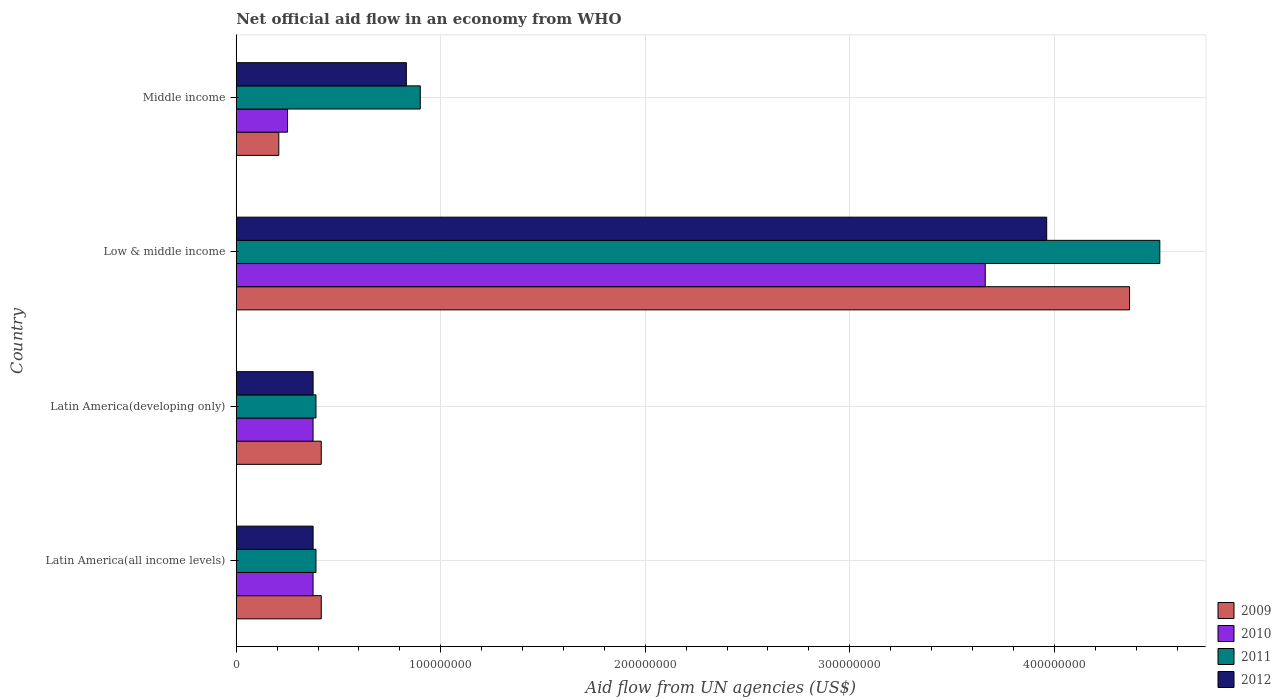How many groups of bars are there?
Give a very brief answer. 4. Are the number of bars per tick equal to the number of legend labels?
Keep it short and to the point. Yes. How many bars are there on the 3rd tick from the top?
Your answer should be very brief. 4. What is the label of the 3rd group of bars from the top?
Keep it short and to the point. Latin America(developing only). What is the net official aid flow in 2010 in Low & middle income?
Ensure brevity in your answer.  3.66e+08. Across all countries, what is the maximum net official aid flow in 2009?
Keep it short and to the point. 4.37e+08. Across all countries, what is the minimum net official aid flow in 2012?
Keep it short and to the point. 3.76e+07. In which country was the net official aid flow in 2011 minimum?
Offer a very short reply. Latin America(all income levels). What is the total net official aid flow in 2009 in the graph?
Your response must be concise. 5.41e+08. What is the difference between the net official aid flow in 2010 in Low & middle income and that in Middle income?
Your answer should be compact. 3.41e+08. What is the difference between the net official aid flow in 2012 in Middle income and the net official aid flow in 2009 in Low & middle income?
Your answer should be compact. -3.54e+08. What is the average net official aid flow in 2011 per country?
Offer a very short reply. 1.55e+08. What is the ratio of the net official aid flow in 2011 in Latin America(all income levels) to that in Low & middle income?
Provide a succinct answer. 0.09. What is the difference between the highest and the second highest net official aid flow in 2012?
Give a very brief answer. 3.13e+08. What is the difference between the highest and the lowest net official aid flow in 2012?
Offer a terse response. 3.59e+08. Is it the case that in every country, the sum of the net official aid flow in 2010 and net official aid flow in 2009 is greater than the sum of net official aid flow in 2011 and net official aid flow in 2012?
Offer a terse response. No. What does the 3rd bar from the top in Middle income represents?
Make the answer very short. 2010. What does the 4th bar from the bottom in Latin America(developing only) represents?
Provide a short and direct response. 2012. Does the graph contain any zero values?
Make the answer very short. No. Does the graph contain grids?
Give a very brief answer. Yes. Where does the legend appear in the graph?
Keep it short and to the point. Bottom right. How are the legend labels stacked?
Your answer should be compact. Vertical. What is the title of the graph?
Give a very brief answer. Net official aid flow in an economy from WHO. Does "2010" appear as one of the legend labels in the graph?
Provide a succinct answer. Yes. What is the label or title of the X-axis?
Give a very brief answer. Aid flow from UN agencies (US$). What is the Aid flow from UN agencies (US$) in 2009 in Latin America(all income levels)?
Provide a succinct answer. 4.16e+07. What is the Aid flow from UN agencies (US$) in 2010 in Latin America(all income levels)?
Your answer should be very brief. 3.76e+07. What is the Aid flow from UN agencies (US$) of 2011 in Latin America(all income levels)?
Your answer should be very brief. 3.90e+07. What is the Aid flow from UN agencies (US$) of 2012 in Latin America(all income levels)?
Provide a short and direct response. 3.76e+07. What is the Aid flow from UN agencies (US$) of 2009 in Latin America(developing only)?
Your answer should be compact. 4.16e+07. What is the Aid flow from UN agencies (US$) in 2010 in Latin America(developing only)?
Provide a succinct answer. 3.76e+07. What is the Aid flow from UN agencies (US$) of 2011 in Latin America(developing only)?
Keep it short and to the point. 3.90e+07. What is the Aid flow from UN agencies (US$) of 2012 in Latin America(developing only)?
Provide a succinct answer. 3.76e+07. What is the Aid flow from UN agencies (US$) of 2009 in Low & middle income?
Give a very brief answer. 4.37e+08. What is the Aid flow from UN agencies (US$) in 2010 in Low & middle income?
Provide a succinct answer. 3.66e+08. What is the Aid flow from UN agencies (US$) of 2011 in Low & middle income?
Your response must be concise. 4.52e+08. What is the Aid flow from UN agencies (US$) in 2012 in Low & middle income?
Give a very brief answer. 3.96e+08. What is the Aid flow from UN agencies (US$) in 2009 in Middle income?
Provide a short and direct response. 2.08e+07. What is the Aid flow from UN agencies (US$) in 2010 in Middle income?
Ensure brevity in your answer.  2.51e+07. What is the Aid flow from UN agencies (US$) in 2011 in Middle income?
Your response must be concise. 9.00e+07. What is the Aid flow from UN agencies (US$) in 2012 in Middle income?
Make the answer very short. 8.32e+07. Across all countries, what is the maximum Aid flow from UN agencies (US$) of 2009?
Your response must be concise. 4.37e+08. Across all countries, what is the maximum Aid flow from UN agencies (US$) of 2010?
Keep it short and to the point. 3.66e+08. Across all countries, what is the maximum Aid flow from UN agencies (US$) of 2011?
Offer a very short reply. 4.52e+08. Across all countries, what is the maximum Aid flow from UN agencies (US$) of 2012?
Ensure brevity in your answer.  3.96e+08. Across all countries, what is the minimum Aid flow from UN agencies (US$) in 2009?
Your response must be concise. 2.08e+07. Across all countries, what is the minimum Aid flow from UN agencies (US$) in 2010?
Offer a terse response. 2.51e+07. Across all countries, what is the minimum Aid flow from UN agencies (US$) in 2011?
Give a very brief answer. 3.90e+07. Across all countries, what is the minimum Aid flow from UN agencies (US$) of 2012?
Offer a very short reply. 3.76e+07. What is the total Aid flow from UN agencies (US$) in 2009 in the graph?
Offer a very short reply. 5.41e+08. What is the total Aid flow from UN agencies (US$) in 2010 in the graph?
Make the answer very short. 4.66e+08. What is the total Aid flow from UN agencies (US$) of 2011 in the graph?
Keep it short and to the point. 6.20e+08. What is the total Aid flow from UN agencies (US$) in 2012 in the graph?
Offer a terse response. 5.55e+08. What is the difference between the Aid flow from UN agencies (US$) in 2009 in Latin America(all income levels) and that in Latin America(developing only)?
Your response must be concise. 0. What is the difference between the Aid flow from UN agencies (US$) in 2009 in Latin America(all income levels) and that in Low & middle income?
Give a very brief answer. -3.95e+08. What is the difference between the Aid flow from UN agencies (US$) in 2010 in Latin America(all income levels) and that in Low & middle income?
Your answer should be very brief. -3.29e+08. What is the difference between the Aid flow from UN agencies (US$) in 2011 in Latin America(all income levels) and that in Low & middle income?
Your response must be concise. -4.13e+08. What is the difference between the Aid flow from UN agencies (US$) of 2012 in Latin America(all income levels) and that in Low & middle income?
Keep it short and to the point. -3.59e+08. What is the difference between the Aid flow from UN agencies (US$) in 2009 in Latin America(all income levels) and that in Middle income?
Your response must be concise. 2.08e+07. What is the difference between the Aid flow from UN agencies (US$) of 2010 in Latin America(all income levels) and that in Middle income?
Your answer should be compact. 1.25e+07. What is the difference between the Aid flow from UN agencies (US$) in 2011 in Latin America(all income levels) and that in Middle income?
Provide a succinct answer. -5.10e+07. What is the difference between the Aid flow from UN agencies (US$) in 2012 in Latin America(all income levels) and that in Middle income?
Your answer should be compact. -4.56e+07. What is the difference between the Aid flow from UN agencies (US$) in 2009 in Latin America(developing only) and that in Low & middle income?
Ensure brevity in your answer.  -3.95e+08. What is the difference between the Aid flow from UN agencies (US$) of 2010 in Latin America(developing only) and that in Low & middle income?
Keep it short and to the point. -3.29e+08. What is the difference between the Aid flow from UN agencies (US$) of 2011 in Latin America(developing only) and that in Low & middle income?
Keep it short and to the point. -4.13e+08. What is the difference between the Aid flow from UN agencies (US$) of 2012 in Latin America(developing only) and that in Low & middle income?
Provide a succinct answer. -3.59e+08. What is the difference between the Aid flow from UN agencies (US$) in 2009 in Latin America(developing only) and that in Middle income?
Give a very brief answer. 2.08e+07. What is the difference between the Aid flow from UN agencies (US$) in 2010 in Latin America(developing only) and that in Middle income?
Provide a short and direct response. 1.25e+07. What is the difference between the Aid flow from UN agencies (US$) of 2011 in Latin America(developing only) and that in Middle income?
Keep it short and to the point. -5.10e+07. What is the difference between the Aid flow from UN agencies (US$) in 2012 in Latin America(developing only) and that in Middle income?
Provide a short and direct response. -4.56e+07. What is the difference between the Aid flow from UN agencies (US$) in 2009 in Low & middle income and that in Middle income?
Provide a short and direct response. 4.16e+08. What is the difference between the Aid flow from UN agencies (US$) in 2010 in Low & middle income and that in Middle income?
Offer a terse response. 3.41e+08. What is the difference between the Aid flow from UN agencies (US$) of 2011 in Low & middle income and that in Middle income?
Your answer should be compact. 3.62e+08. What is the difference between the Aid flow from UN agencies (US$) in 2012 in Low & middle income and that in Middle income?
Your answer should be compact. 3.13e+08. What is the difference between the Aid flow from UN agencies (US$) in 2009 in Latin America(all income levels) and the Aid flow from UN agencies (US$) in 2010 in Latin America(developing only)?
Provide a short and direct response. 4.01e+06. What is the difference between the Aid flow from UN agencies (US$) in 2009 in Latin America(all income levels) and the Aid flow from UN agencies (US$) in 2011 in Latin America(developing only)?
Offer a terse response. 2.59e+06. What is the difference between the Aid flow from UN agencies (US$) in 2009 in Latin America(all income levels) and the Aid flow from UN agencies (US$) in 2012 in Latin America(developing only)?
Your response must be concise. 3.99e+06. What is the difference between the Aid flow from UN agencies (US$) in 2010 in Latin America(all income levels) and the Aid flow from UN agencies (US$) in 2011 in Latin America(developing only)?
Ensure brevity in your answer.  -1.42e+06. What is the difference between the Aid flow from UN agencies (US$) in 2011 in Latin America(all income levels) and the Aid flow from UN agencies (US$) in 2012 in Latin America(developing only)?
Ensure brevity in your answer.  1.40e+06. What is the difference between the Aid flow from UN agencies (US$) of 2009 in Latin America(all income levels) and the Aid flow from UN agencies (US$) of 2010 in Low & middle income?
Your response must be concise. -3.25e+08. What is the difference between the Aid flow from UN agencies (US$) of 2009 in Latin America(all income levels) and the Aid flow from UN agencies (US$) of 2011 in Low & middle income?
Your answer should be very brief. -4.10e+08. What is the difference between the Aid flow from UN agencies (US$) of 2009 in Latin America(all income levels) and the Aid flow from UN agencies (US$) of 2012 in Low & middle income?
Give a very brief answer. -3.55e+08. What is the difference between the Aid flow from UN agencies (US$) in 2010 in Latin America(all income levels) and the Aid flow from UN agencies (US$) in 2011 in Low & middle income?
Your answer should be very brief. -4.14e+08. What is the difference between the Aid flow from UN agencies (US$) in 2010 in Latin America(all income levels) and the Aid flow from UN agencies (US$) in 2012 in Low & middle income?
Your answer should be very brief. -3.59e+08. What is the difference between the Aid flow from UN agencies (US$) in 2011 in Latin America(all income levels) and the Aid flow from UN agencies (US$) in 2012 in Low & middle income?
Provide a short and direct response. -3.57e+08. What is the difference between the Aid flow from UN agencies (US$) in 2009 in Latin America(all income levels) and the Aid flow from UN agencies (US$) in 2010 in Middle income?
Provide a succinct answer. 1.65e+07. What is the difference between the Aid flow from UN agencies (US$) in 2009 in Latin America(all income levels) and the Aid flow from UN agencies (US$) in 2011 in Middle income?
Make the answer very short. -4.84e+07. What is the difference between the Aid flow from UN agencies (US$) of 2009 in Latin America(all income levels) and the Aid flow from UN agencies (US$) of 2012 in Middle income?
Give a very brief answer. -4.16e+07. What is the difference between the Aid flow from UN agencies (US$) of 2010 in Latin America(all income levels) and the Aid flow from UN agencies (US$) of 2011 in Middle income?
Keep it short and to the point. -5.24e+07. What is the difference between the Aid flow from UN agencies (US$) in 2010 in Latin America(all income levels) and the Aid flow from UN agencies (US$) in 2012 in Middle income?
Your response must be concise. -4.56e+07. What is the difference between the Aid flow from UN agencies (US$) in 2011 in Latin America(all income levels) and the Aid flow from UN agencies (US$) in 2012 in Middle income?
Provide a succinct answer. -4.42e+07. What is the difference between the Aid flow from UN agencies (US$) in 2009 in Latin America(developing only) and the Aid flow from UN agencies (US$) in 2010 in Low & middle income?
Your answer should be compact. -3.25e+08. What is the difference between the Aid flow from UN agencies (US$) of 2009 in Latin America(developing only) and the Aid flow from UN agencies (US$) of 2011 in Low & middle income?
Give a very brief answer. -4.10e+08. What is the difference between the Aid flow from UN agencies (US$) of 2009 in Latin America(developing only) and the Aid flow from UN agencies (US$) of 2012 in Low & middle income?
Offer a terse response. -3.55e+08. What is the difference between the Aid flow from UN agencies (US$) in 2010 in Latin America(developing only) and the Aid flow from UN agencies (US$) in 2011 in Low & middle income?
Your answer should be very brief. -4.14e+08. What is the difference between the Aid flow from UN agencies (US$) in 2010 in Latin America(developing only) and the Aid flow from UN agencies (US$) in 2012 in Low & middle income?
Your answer should be very brief. -3.59e+08. What is the difference between the Aid flow from UN agencies (US$) of 2011 in Latin America(developing only) and the Aid flow from UN agencies (US$) of 2012 in Low & middle income?
Keep it short and to the point. -3.57e+08. What is the difference between the Aid flow from UN agencies (US$) of 2009 in Latin America(developing only) and the Aid flow from UN agencies (US$) of 2010 in Middle income?
Provide a short and direct response. 1.65e+07. What is the difference between the Aid flow from UN agencies (US$) in 2009 in Latin America(developing only) and the Aid flow from UN agencies (US$) in 2011 in Middle income?
Your answer should be compact. -4.84e+07. What is the difference between the Aid flow from UN agencies (US$) of 2009 in Latin America(developing only) and the Aid flow from UN agencies (US$) of 2012 in Middle income?
Keep it short and to the point. -4.16e+07. What is the difference between the Aid flow from UN agencies (US$) of 2010 in Latin America(developing only) and the Aid flow from UN agencies (US$) of 2011 in Middle income?
Your response must be concise. -5.24e+07. What is the difference between the Aid flow from UN agencies (US$) in 2010 in Latin America(developing only) and the Aid flow from UN agencies (US$) in 2012 in Middle income?
Offer a very short reply. -4.56e+07. What is the difference between the Aid flow from UN agencies (US$) of 2011 in Latin America(developing only) and the Aid flow from UN agencies (US$) of 2012 in Middle income?
Keep it short and to the point. -4.42e+07. What is the difference between the Aid flow from UN agencies (US$) of 2009 in Low & middle income and the Aid flow from UN agencies (US$) of 2010 in Middle income?
Your answer should be compact. 4.12e+08. What is the difference between the Aid flow from UN agencies (US$) in 2009 in Low & middle income and the Aid flow from UN agencies (US$) in 2011 in Middle income?
Your response must be concise. 3.47e+08. What is the difference between the Aid flow from UN agencies (US$) in 2009 in Low & middle income and the Aid flow from UN agencies (US$) in 2012 in Middle income?
Your response must be concise. 3.54e+08. What is the difference between the Aid flow from UN agencies (US$) in 2010 in Low & middle income and the Aid flow from UN agencies (US$) in 2011 in Middle income?
Offer a terse response. 2.76e+08. What is the difference between the Aid flow from UN agencies (US$) in 2010 in Low & middle income and the Aid flow from UN agencies (US$) in 2012 in Middle income?
Keep it short and to the point. 2.83e+08. What is the difference between the Aid flow from UN agencies (US$) of 2011 in Low & middle income and the Aid flow from UN agencies (US$) of 2012 in Middle income?
Your response must be concise. 3.68e+08. What is the average Aid flow from UN agencies (US$) of 2009 per country?
Your response must be concise. 1.35e+08. What is the average Aid flow from UN agencies (US$) in 2010 per country?
Give a very brief answer. 1.17e+08. What is the average Aid flow from UN agencies (US$) in 2011 per country?
Your answer should be very brief. 1.55e+08. What is the average Aid flow from UN agencies (US$) of 2012 per country?
Make the answer very short. 1.39e+08. What is the difference between the Aid flow from UN agencies (US$) of 2009 and Aid flow from UN agencies (US$) of 2010 in Latin America(all income levels)?
Keep it short and to the point. 4.01e+06. What is the difference between the Aid flow from UN agencies (US$) of 2009 and Aid flow from UN agencies (US$) of 2011 in Latin America(all income levels)?
Keep it short and to the point. 2.59e+06. What is the difference between the Aid flow from UN agencies (US$) in 2009 and Aid flow from UN agencies (US$) in 2012 in Latin America(all income levels)?
Your response must be concise. 3.99e+06. What is the difference between the Aid flow from UN agencies (US$) of 2010 and Aid flow from UN agencies (US$) of 2011 in Latin America(all income levels)?
Your response must be concise. -1.42e+06. What is the difference between the Aid flow from UN agencies (US$) in 2011 and Aid flow from UN agencies (US$) in 2012 in Latin America(all income levels)?
Make the answer very short. 1.40e+06. What is the difference between the Aid flow from UN agencies (US$) of 2009 and Aid flow from UN agencies (US$) of 2010 in Latin America(developing only)?
Give a very brief answer. 4.01e+06. What is the difference between the Aid flow from UN agencies (US$) in 2009 and Aid flow from UN agencies (US$) in 2011 in Latin America(developing only)?
Provide a succinct answer. 2.59e+06. What is the difference between the Aid flow from UN agencies (US$) of 2009 and Aid flow from UN agencies (US$) of 2012 in Latin America(developing only)?
Your answer should be compact. 3.99e+06. What is the difference between the Aid flow from UN agencies (US$) in 2010 and Aid flow from UN agencies (US$) in 2011 in Latin America(developing only)?
Give a very brief answer. -1.42e+06. What is the difference between the Aid flow from UN agencies (US$) of 2011 and Aid flow from UN agencies (US$) of 2012 in Latin America(developing only)?
Your answer should be compact. 1.40e+06. What is the difference between the Aid flow from UN agencies (US$) of 2009 and Aid flow from UN agencies (US$) of 2010 in Low & middle income?
Make the answer very short. 7.06e+07. What is the difference between the Aid flow from UN agencies (US$) in 2009 and Aid flow from UN agencies (US$) in 2011 in Low & middle income?
Make the answer very short. -1.48e+07. What is the difference between the Aid flow from UN agencies (US$) in 2009 and Aid flow from UN agencies (US$) in 2012 in Low & middle income?
Provide a succinct answer. 4.05e+07. What is the difference between the Aid flow from UN agencies (US$) in 2010 and Aid flow from UN agencies (US$) in 2011 in Low & middle income?
Ensure brevity in your answer.  -8.54e+07. What is the difference between the Aid flow from UN agencies (US$) in 2010 and Aid flow from UN agencies (US$) in 2012 in Low & middle income?
Give a very brief answer. -3.00e+07. What is the difference between the Aid flow from UN agencies (US$) in 2011 and Aid flow from UN agencies (US$) in 2012 in Low & middle income?
Ensure brevity in your answer.  5.53e+07. What is the difference between the Aid flow from UN agencies (US$) in 2009 and Aid flow from UN agencies (US$) in 2010 in Middle income?
Provide a short and direct response. -4.27e+06. What is the difference between the Aid flow from UN agencies (US$) in 2009 and Aid flow from UN agencies (US$) in 2011 in Middle income?
Give a very brief answer. -6.92e+07. What is the difference between the Aid flow from UN agencies (US$) in 2009 and Aid flow from UN agencies (US$) in 2012 in Middle income?
Ensure brevity in your answer.  -6.24e+07. What is the difference between the Aid flow from UN agencies (US$) of 2010 and Aid flow from UN agencies (US$) of 2011 in Middle income?
Provide a succinct answer. -6.49e+07. What is the difference between the Aid flow from UN agencies (US$) of 2010 and Aid flow from UN agencies (US$) of 2012 in Middle income?
Offer a terse response. -5.81e+07. What is the difference between the Aid flow from UN agencies (US$) of 2011 and Aid flow from UN agencies (US$) of 2012 in Middle income?
Provide a short and direct response. 6.80e+06. What is the ratio of the Aid flow from UN agencies (US$) of 2012 in Latin America(all income levels) to that in Latin America(developing only)?
Offer a very short reply. 1. What is the ratio of the Aid flow from UN agencies (US$) of 2009 in Latin America(all income levels) to that in Low & middle income?
Ensure brevity in your answer.  0.1. What is the ratio of the Aid flow from UN agencies (US$) of 2010 in Latin America(all income levels) to that in Low & middle income?
Offer a very short reply. 0.1. What is the ratio of the Aid flow from UN agencies (US$) in 2011 in Latin America(all income levels) to that in Low & middle income?
Provide a short and direct response. 0.09. What is the ratio of the Aid flow from UN agencies (US$) of 2012 in Latin America(all income levels) to that in Low & middle income?
Offer a terse response. 0.09. What is the ratio of the Aid flow from UN agencies (US$) in 2009 in Latin America(all income levels) to that in Middle income?
Offer a terse response. 2. What is the ratio of the Aid flow from UN agencies (US$) in 2010 in Latin America(all income levels) to that in Middle income?
Ensure brevity in your answer.  1.5. What is the ratio of the Aid flow from UN agencies (US$) of 2011 in Latin America(all income levels) to that in Middle income?
Keep it short and to the point. 0.43. What is the ratio of the Aid flow from UN agencies (US$) of 2012 in Latin America(all income levels) to that in Middle income?
Provide a succinct answer. 0.45. What is the ratio of the Aid flow from UN agencies (US$) in 2009 in Latin America(developing only) to that in Low & middle income?
Your answer should be very brief. 0.1. What is the ratio of the Aid flow from UN agencies (US$) of 2010 in Latin America(developing only) to that in Low & middle income?
Ensure brevity in your answer.  0.1. What is the ratio of the Aid flow from UN agencies (US$) of 2011 in Latin America(developing only) to that in Low & middle income?
Your response must be concise. 0.09. What is the ratio of the Aid flow from UN agencies (US$) of 2012 in Latin America(developing only) to that in Low & middle income?
Offer a terse response. 0.09. What is the ratio of the Aid flow from UN agencies (US$) in 2009 in Latin America(developing only) to that in Middle income?
Your answer should be compact. 2. What is the ratio of the Aid flow from UN agencies (US$) of 2010 in Latin America(developing only) to that in Middle income?
Your answer should be compact. 1.5. What is the ratio of the Aid flow from UN agencies (US$) of 2011 in Latin America(developing only) to that in Middle income?
Your answer should be very brief. 0.43. What is the ratio of the Aid flow from UN agencies (US$) in 2012 in Latin America(developing only) to that in Middle income?
Keep it short and to the point. 0.45. What is the ratio of the Aid flow from UN agencies (US$) of 2009 in Low & middle income to that in Middle income?
Offer a very short reply. 21. What is the ratio of the Aid flow from UN agencies (US$) of 2010 in Low & middle income to that in Middle income?
Your answer should be compact. 14.61. What is the ratio of the Aid flow from UN agencies (US$) in 2011 in Low & middle income to that in Middle income?
Your answer should be very brief. 5.02. What is the ratio of the Aid flow from UN agencies (US$) of 2012 in Low & middle income to that in Middle income?
Offer a very short reply. 4.76. What is the difference between the highest and the second highest Aid flow from UN agencies (US$) of 2009?
Offer a very short reply. 3.95e+08. What is the difference between the highest and the second highest Aid flow from UN agencies (US$) in 2010?
Your response must be concise. 3.29e+08. What is the difference between the highest and the second highest Aid flow from UN agencies (US$) of 2011?
Keep it short and to the point. 3.62e+08. What is the difference between the highest and the second highest Aid flow from UN agencies (US$) in 2012?
Provide a succinct answer. 3.13e+08. What is the difference between the highest and the lowest Aid flow from UN agencies (US$) in 2009?
Your answer should be compact. 4.16e+08. What is the difference between the highest and the lowest Aid flow from UN agencies (US$) in 2010?
Keep it short and to the point. 3.41e+08. What is the difference between the highest and the lowest Aid flow from UN agencies (US$) in 2011?
Offer a very short reply. 4.13e+08. What is the difference between the highest and the lowest Aid flow from UN agencies (US$) of 2012?
Provide a succinct answer. 3.59e+08. 